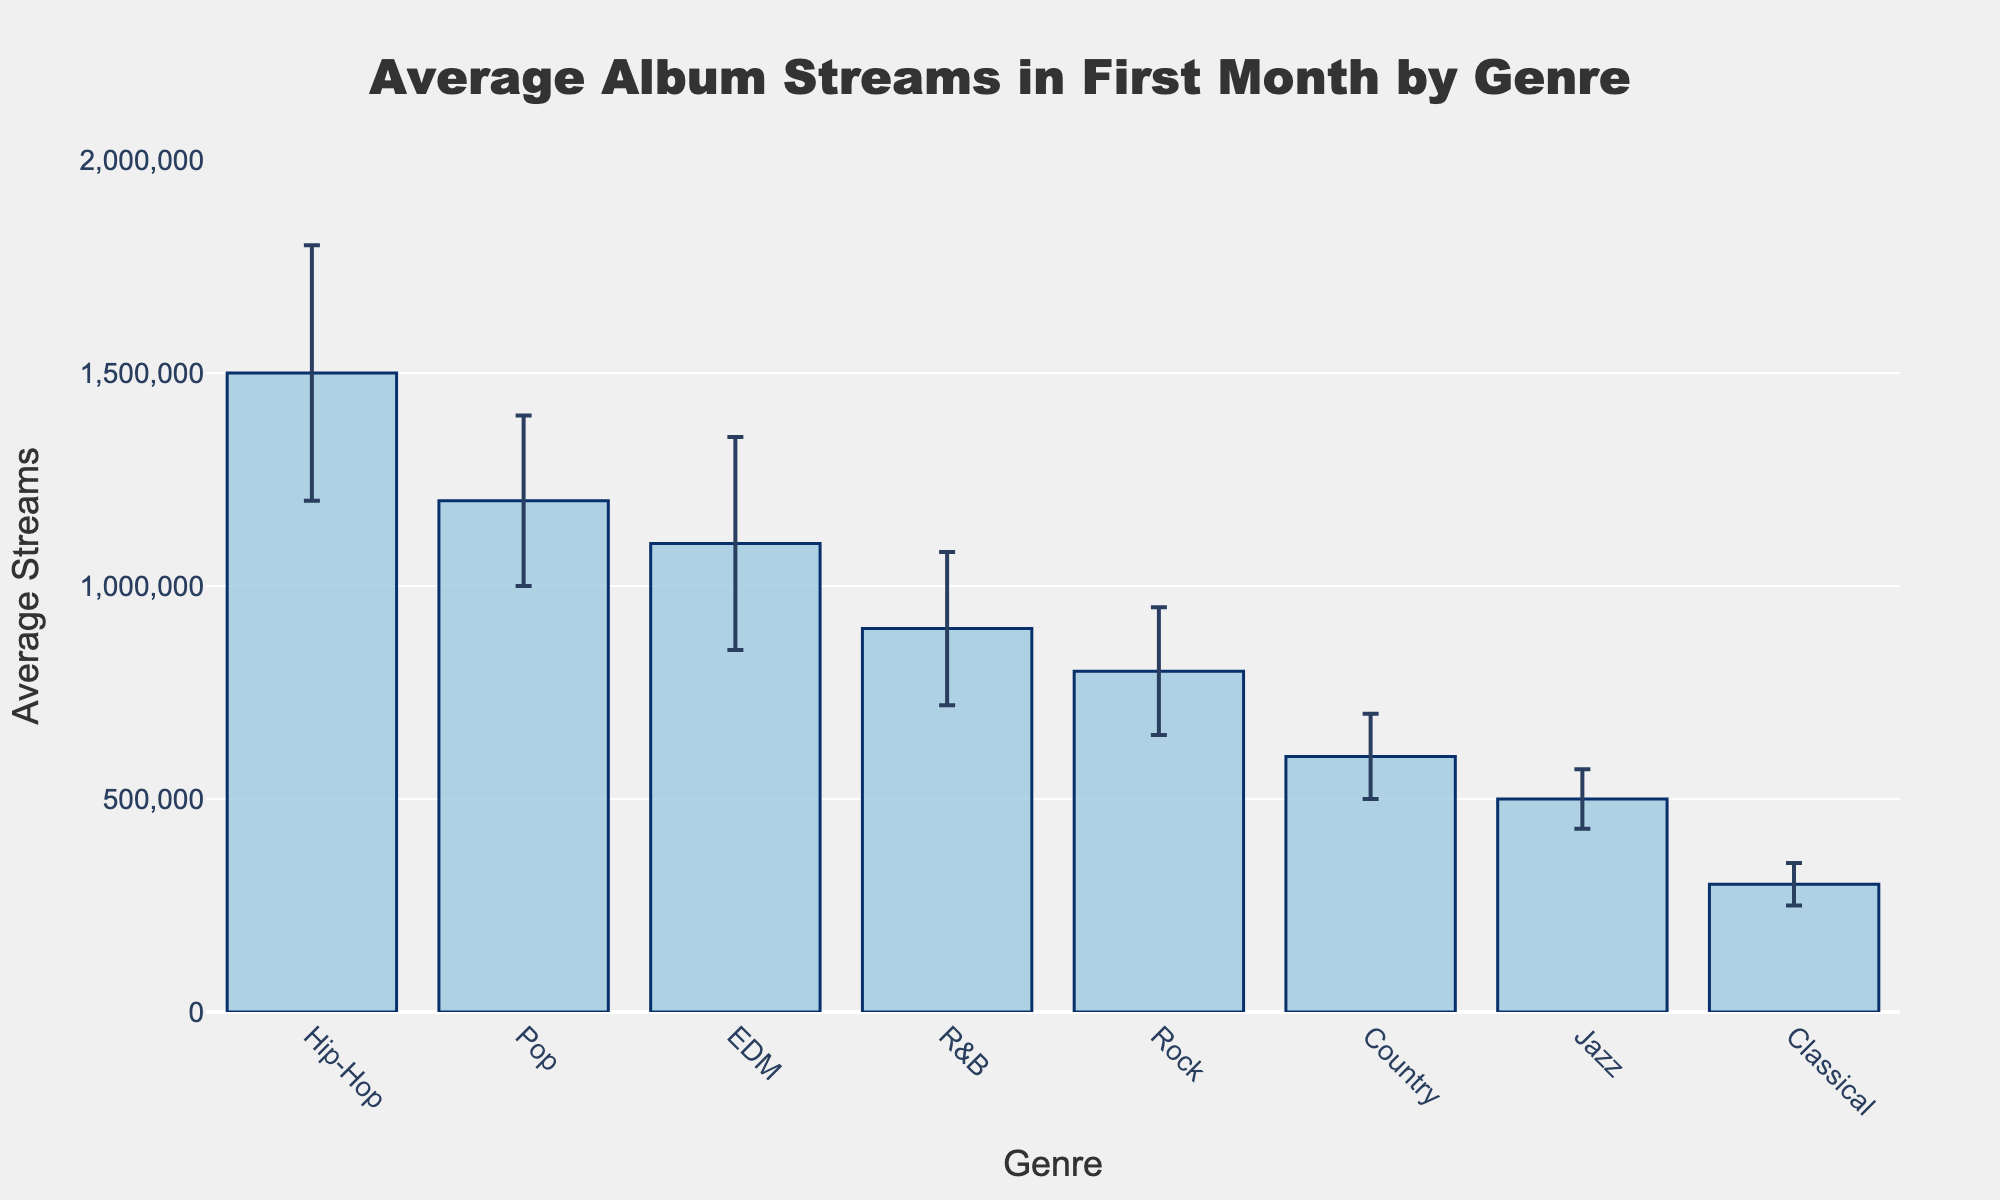What's the average number of album streams in the first month for the Pop genre? The average number of album streams for the Pop genre is given directly in the figure. It is represented by the bar's height on the plot.
Answer: 1,200,000 What is the genre with the highest average number of album streams in the first month after release? By looking at the bar heights on the figure, the genre with the highest bar represents the highest average number of album streams.
Answer: Hip-Hop How much higher is the average number of streams for EDM compared to Rock? To find the difference, subtract the average streams of Rock from EDM. EDM has 1,100,000 and Rock has 800,000.
Answer: 300,000 What is the range of the standard deviation for the Hip-Hop genre? The standard deviation for Hip-Hop is given directly as 300,000. The range of possible album streams for Hip-Hop in the first month can be estimated by adding and subtracting this value from the average.
Answer: 1,200,000 to 1,800,000 Which genre has the smallest standard deviation? The smallest standard deviation corresponds to the genre with the shortest error bar.
Answer: Classical What is the total average number of streams in the first month for Pop and Country combined? Add the average streams for Pop and Country: 1,200,000 (Pop) + 600,000 (Country).
Answer: 1,800,000 How does the average number of album streams for Jazz compare to Classical? Compare the bar heights for Jazz and Classical. The bar for Jazz is higher than for Classical.
Answer: Jazz is higher Which three genres have the most similar average number of streams? Look for the genres with bars closest in height. EDM, R&B, and Pop are all close in height.
Answer: EDM, R&B, Pop What is the approximate overall average number of album streams across all genres? Calculate by summing all the averages and dividing by the number of genres. (1,200,000 + 800,000 + 1,500,000 + 600,000 + 900,000 + 1,100,000 + 500,000 + 300,000) / 8
Answer: 862,500 